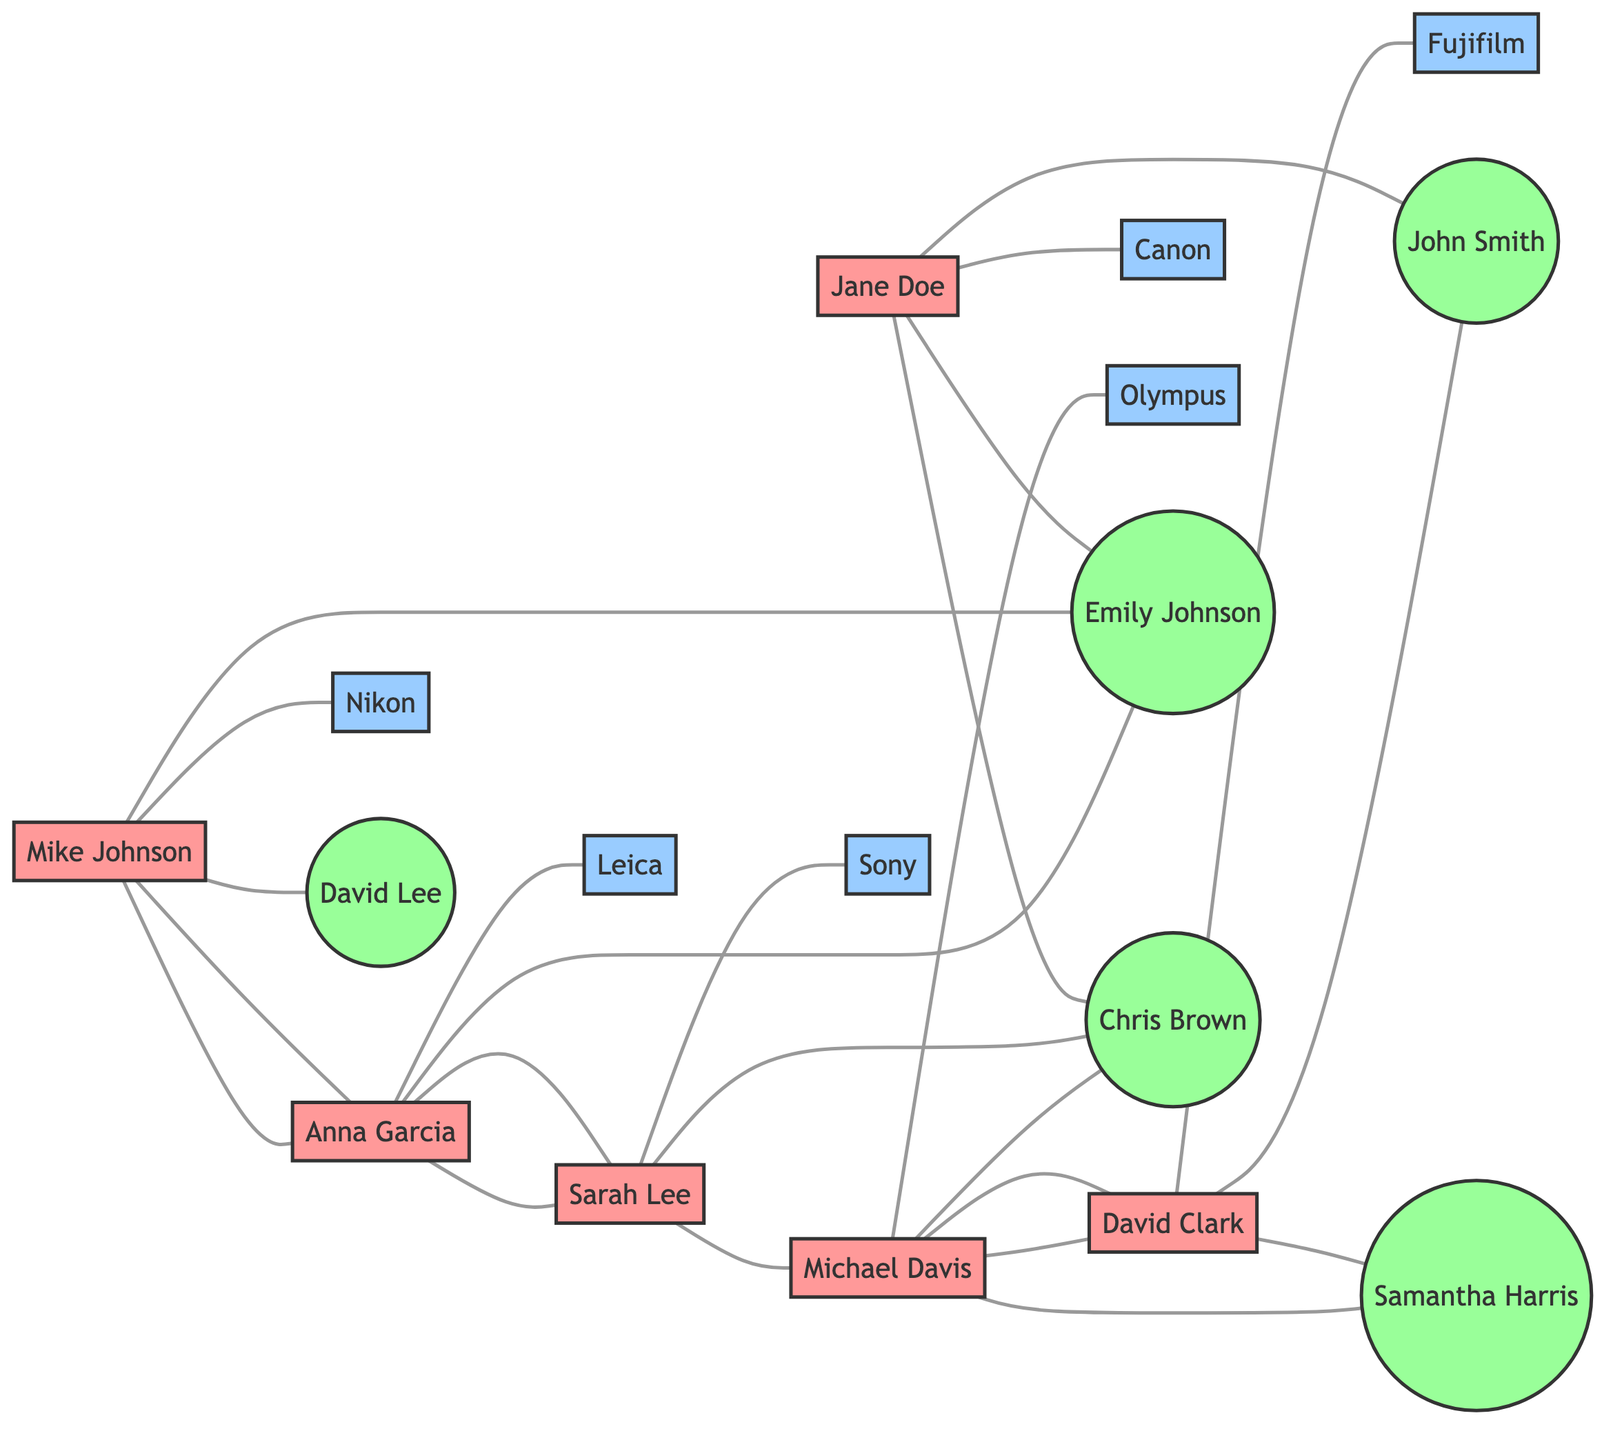What camera brand does Jane Doe collaborate with? Jane Doe is connected to the Canon node in the diagram, which indicates that she collaborates with Canon.
Answer: Canon How many mutual followers does Mike Johnson have? By examining Mike Johnson's connections in the diagram, he has three mutual followers: Emily Johnson, Anna Garcia, and David Lee.
Answer: 3 Who are the mutual followers of Sarah Lee? Sarah Lee is connected to three mutual followers: Chris Brown, Michael Davis, and Anna Garcia, as shown by the connections in the diagram.
Answer: Chris Brown, Michael Davis, Anna Garcia Which influencer collaborates with Fujifilm? David Clark is the influencer connected to the Fujifilm node, indicating his collaboration with that camera brand.
Answer: David Clark Is there any influencer who shares mutual followers with both Canon and Nikon? To evaluate this, we check the mutual followers of Jane Doe (Canon) and Mike Johnson (Nikon). The shared mutual follower is Emily Johnson.
Answer: Yes How many total influencers are represented in the diagram? Counting all the influencer nodes in the diagram, we find a total of six influencers: Jane Doe, Mike Johnson, Sarah Lee, David Clark, Anna Garcia, and Michael Davis.
Answer: 6 Which camera brand does Anna Garcia collaborate with? The diagram shows that Anna Garcia is connected to the Leica node, indicating her collaboration with that camera brand.
Answer: Leica What is the relationship between Michael Davis and David Clark? The relationship is such that both influencers are connected through mutual followers; Michael Davis and David Clark share the mutual followers John Smith and Chris Brown.
Answer: Mutual followers What are the mutual followers of Michael Davis? Michael Davis has connections to David Clark, Chris Brown, and Samantha Harris; thus, these are his mutual followers.
Answer: David Clark, Chris Brown, Samantha Harris 